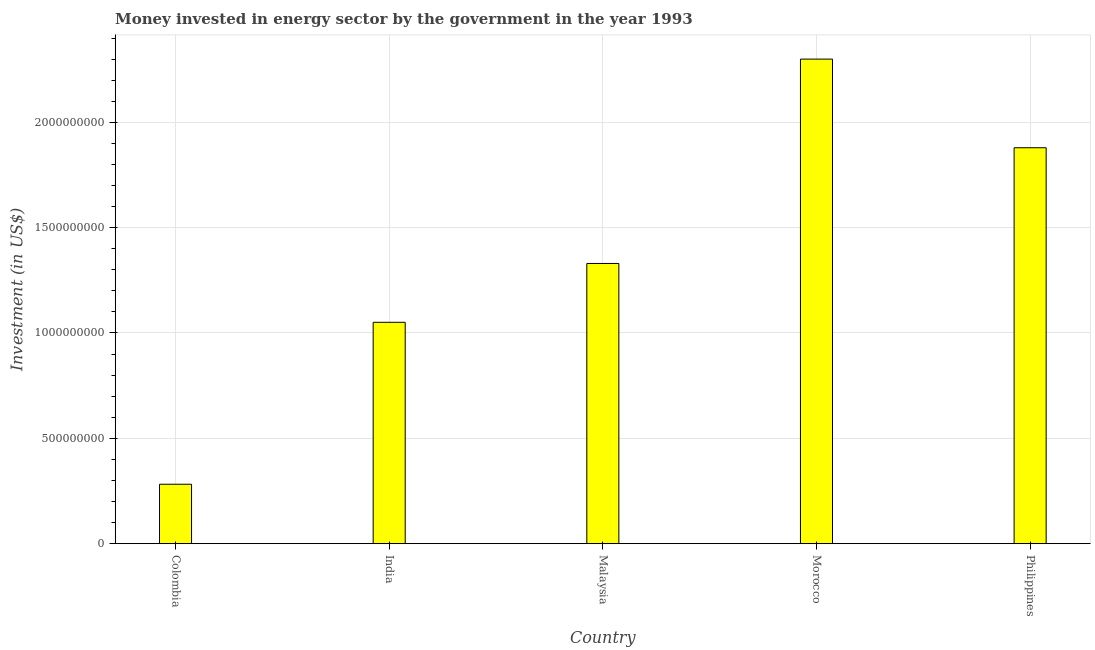Does the graph contain any zero values?
Ensure brevity in your answer.  No. What is the title of the graph?
Your answer should be compact. Money invested in energy sector by the government in the year 1993. What is the label or title of the Y-axis?
Offer a very short reply. Investment (in US$). What is the investment in energy in Colombia?
Make the answer very short. 2.82e+08. Across all countries, what is the maximum investment in energy?
Make the answer very short. 2.30e+09. Across all countries, what is the minimum investment in energy?
Make the answer very short. 2.82e+08. In which country was the investment in energy maximum?
Make the answer very short. Morocco. What is the sum of the investment in energy?
Offer a terse response. 6.84e+09. What is the difference between the investment in energy in Colombia and Malaysia?
Your response must be concise. -1.05e+09. What is the average investment in energy per country?
Keep it short and to the point. 1.37e+09. What is the median investment in energy?
Make the answer very short. 1.33e+09. What is the ratio of the investment in energy in India to that in Philippines?
Ensure brevity in your answer.  0.56. Is the investment in energy in Malaysia less than that in Philippines?
Make the answer very short. Yes. Is the difference between the investment in energy in Colombia and Philippines greater than the difference between any two countries?
Keep it short and to the point. No. What is the difference between the highest and the second highest investment in energy?
Make the answer very short. 4.21e+08. What is the difference between the highest and the lowest investment in energy?
Provide a succinct answer. 2.02e+09. How many bars are there?
Provide a succinct answer. 5. Are all the bars in the graph horizontal?
Keep it short and to the point. No. How many countries are there in the graph?
Give a very brief answer. 5. What is the Investment (in US$) of Colombia?
Your answer should be very brief. 2.82e+08. What is the Investment (in US$) in India?
Give a very brief answer. 1.05e+09. What is the Investment (in US$) of Malaysia?
Ensure brevity in your answer.  1.33e+09. What is the Investment (in US$) of Morocco?
Your response must be concise. 2.30e+09. What is the Investment (in US$) of Philippines?
Provide a succinct answer. 1.88e+09. What is the difference between the Investment (in US$) in Colombia and India?
Offer a terse response. -7.69e+08. What is the difference between the Investment (in US$) in Colombia and Malaysia?
Offer a very short reply. -1.05e+09. What is the difference between the Investment (in US$) in Colombia and Morocco?
Offer a terse response. -2.02e+09. What is the difference between the Investment (in US$) in Colombia and Philippines?
Provide a succinct answer. -1.60e+09. What is the difference between the Investment (in US$) in India and Malaysia?
Your answer should be compact. -2.79e+08. What is the difference between the Investment (in US$) in India and Morocco?
Give a very brief answer. -1.25e+09. What is the difference between the Investment (in US$) in India and Philippines?
Offer a very short reply. -8.29e+08. What is the difference between the Investment (in US$) in Malaysia and Morocco?
Keep it short and to the point. -9.70e+08. What is the difference between the Investment (in US$) in Malaysia and Philippines?
Keep it short and to the point. -5.49e+08. What is the difference between the Investment (in US$) in Morocco and Philippines?
Your answer should be very brief. 4.21e+08. What is the ratio of the Investment (in US$) in Colombia to that in India?
Keep it short and to the point. 0.27. What is the ratio of the Investment (in US$) in Colombia to that in Malaysia?
Your response must be concise. 0.21. What is the ratio of the Investment (in US$) in Colombia to that in Morocco?
Provide a succinct answer. 0.12. What is the ratio of the Investment (in US$) in Colombia to that in Philippines?
Your answer should be very brief. 0.15. What is the ratio of the Investment (in US$) in India to that in Malaysia?
Your answer should be very brief. 0.79. What is the ratio of the Investment (in US$) in India to that in Morocco?
Ensure brevity in your answer.  0.46. What is the ratio of the Investment (in US$) in India to that in Philippines?
Give a very brief answer. 0.56. What is the ratio of the Investment (in US$) in Malaysia to that in Morocco?
Your answer should be compact. 0.58. What is the ratio of the Investment (in US$) in Malaysia to that in Philippines?
Offer a terse response. 0.71. What is the ratio of the Investment (in US$) in Morocco to that in Philippines?
Make the answer very short. 1.22. 